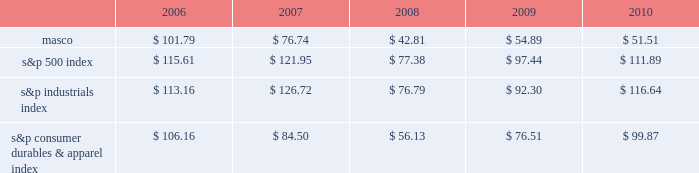Performance graph the table below compares the cumulative total shareholder return on our common stock with the cumulative total return of ( i ) the standard & poor 2019s 500 composite stock index ( 201cs&p 500 index 201d ) , ( ii ) the standard & poor 2019s industrials index ( 201cs&p industrials index 201d ) and ( iii ) the standard & poor 2019s consumer durables & apparel index ( 201cs&p consumer durables & apparel index 201d ) , from december 31 , 2005 through december 31 , 2010 , when the closing price of our common stock was $ 12.66 .
The graph assumes investments of $ 100 on december 31 , 2005 in our common stock and in each of the three indices and the reinvestment of dividends .
Performance graph 201020092008200720062005 s&p 500 index s&p industrials index s&p consumer durables & apparel index the table below sets forth the value , as of december 31 for each of the years indicated , of a $ 100 investment made on december 31 , 2005 in each of our common stock , the s&p 500 index , the s&p industrials index and the s&p consumer durables & apparel index and includes the reinvestment of dividends. .
In july 2007 , our board of directors authorized the purchase of up to 50 million shares of our common stock in open-market transactions or otherwise .
At december 31 , 2010 , we had remaining authorization to repurchase up to 27 million shares .
During 2010 , we repurchased and retired three million shares of our common stock , for cash aggregating $ 45 million to offset the dilutive impact of the 2010 grant of three million shares of long-term stock awards .
We did not purchase any shares during the three months ended december 31 , 2010. .
What was the difference in percentage cumulative total shareholder return on masco common stock versus the s&p 500 index for the five year period ended 2010? 
Computations: (((51.51 - 100) / 100) - ((111.89 - 100) / 100))
Answer: -0.6038. 